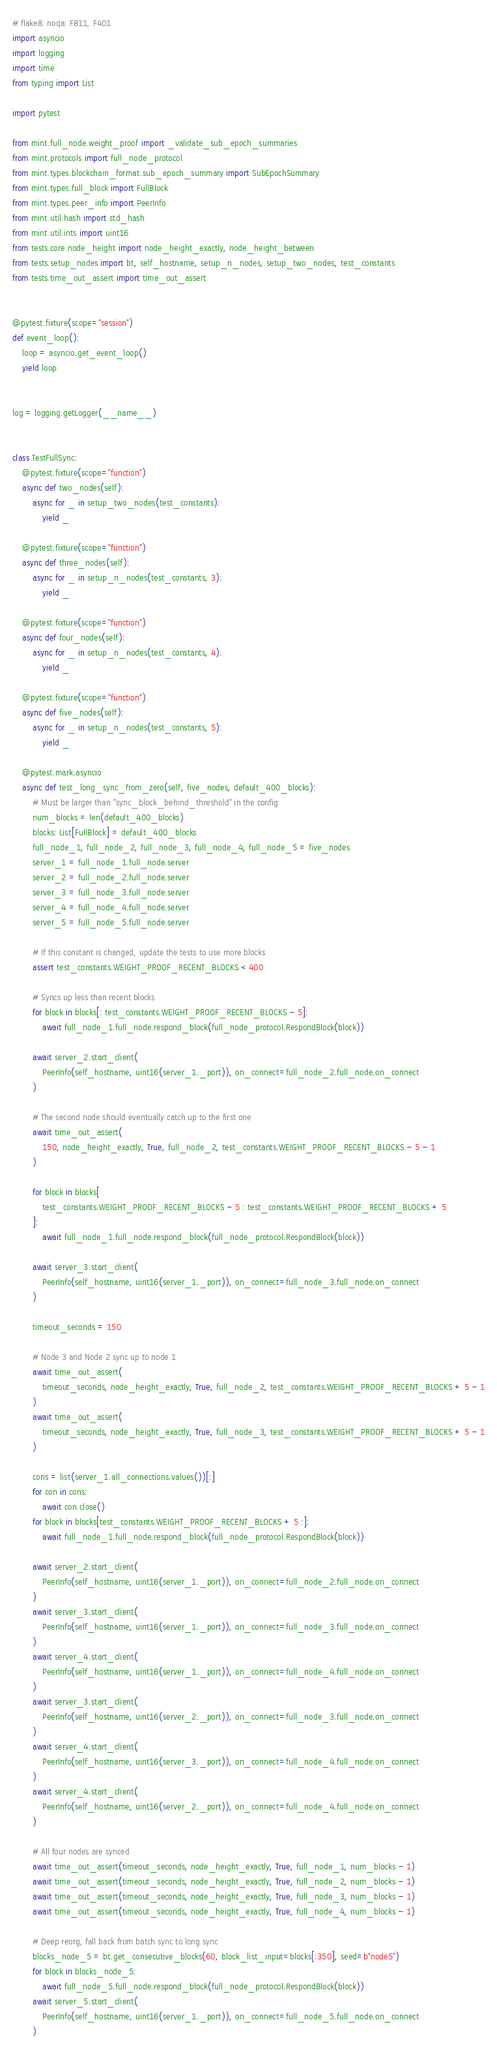<code> <loc_0><loc_0><loc_500><loc_500><_Python_># flake8: noqa: F811, F401
import asyncio
import logging
import time
from typing import List

import pytest

from mint.full_node.weight_proof import _validate_sub_epoch_summaries
from mint.protocols import full_node_protocol
from mint.types.blockchain_format.sub_epoch_summary import SubEpochSummary
from mint.types.full_block import FullBlock
from mint.types.peer_info import PeerInfo
from mint.util.hash import std_hash
from mint.util.ints import uint16
from tests.core.node_height import node_height_exactly, node_height_between
from tests.setup_nodes import bt, self_hostname, setup_n_nodes, setup_two_nodes, test_constants
from tests.time_out_assert import time_out_assert


@pytest.fixture(scope="session")
def event_loop():
    loop = asyncio.get_event_loop()
    yield loop


log = logging.getLogger(__name__)


class TestFullSync:
    @pytest.fixture(scope="function")
    async def two_nodes(self):
        async for _ in setup_two_nodes(test_constants):
            yield _

    @pytest.fixture(scope="function")
    async def three_nodes(self):
        async for _ in setup_n_nodes(test_constants, 3):
            yield _

    @pytest.fixture(scope="function")
    async def four_nodes(self):
        async for _ in setup_n_nodes(test_constants, 4):
            yield _

    @pytest.fixture(scope="function")
    async def five_nodes(self):
        async for _ in setup_n_nodes(test_constants, 5):
            yield _

    @pytest.mark.asyncio
    async def test_long_sync_from_zero(self, five_nodes, default_400_blocks):
        # Must be larger than "sync_block_behind_threshold" in the config
        num_blocks = len(default_400_blocks)
        blocks: List[FullBlock] = default_400_blocks
        full_node_1, full_node_2, full_node_3, full_node_4, full_node_5 = five_nodes
        server_1 = full_node_1.full_node.server
        server_2 = full_node_2.full_node.server
        server_3 = full_node_3.full_node.server
        server_4 = full_node_4.full_node.server
        server_5 = full_node_5.full_node.server

        # If this constant is changed, update the tests to use more blocks
        assert test_constants.WEIGHT_PROOF_RECENT_BLOCKS < 400

        # Syncs up less than recent blocks
        for block in blocks[: test_constants.WEIGHT_PROOF_RECENT_BLOCKS - 5]:
            await full_node_1.full_node.respond_block(full_node_protocol.RespondBlock(block))

        await server_2.start_client(
            PeerInfo(self_hostname, uint16(server_1._port)), on_connect=full_node_2.full_node.on_connect
        )

        # The second node should eventually catch up to the first one
        await time_out_assert(
            150, node_height_exactly, True, full_node_2, test_constants.WEIGHT_PROOF_RECENT_BLOCKS - 5 - 1
        )

        for block in blocks[
            test_constants.WEIGHT_PROOF_RECENT_BLOCKS - 5 : test_constants.WEIGHT_PROOF_RECENT_BLOCKS + 5
        ]:
            await full_node_1.full_node.respond_block(full_node_protocol.RespondBlock(block))

        await server_3.start_client(
            PeerInfo(self_hostname, uint16(server_1._port)), on_connect=full_node_3.full_node.on_connect
        )

        timeout_seconds = 150

        # Node 3 and Node 2 sync up to node 1
        await time_out_assert(
            timeout_seconds, node_height_exactly, True, full_node_2, test_constants.WEIGHT_PROOF_RECENT_BLOCKS + 5 - 1
        )
        await time_out_assert(
            timeout_seconds, node_height_exactly, True, full_node_3, test_constants.WEIGHT_PROOF_RECENT_BLOCKS + 5 - 1
        )

        cons = list(server_1.all_connections.values())[:]
        for con in cons:
            await con.close()
        for block in blocks[test_constants.WEIGHT_PROOF_RECENT_BLOCKS + 5 :]:
            await full_node_1.full_node.respond_block(full_node_protocol.RespondBlock(block))

        await server_2.start_client(
            PeerInfo(self_hostname, uint16(server_1._port)), on_connect=full_node_2.full_node.on_connect
        )
        await server_3.start_client(
            PeerInfo(self_hostname, uint16(server_1._port)), on_connect=full_node_3.full_node.on_connect
        )
        await server_4.start_client(
            PeerInfo(self_hostname, uint16(server_1._port)), on_connect=full_node_4.full_node.on_connect
        )
        await server_3.start_client(
            PeerInfo(self_hostname, uint16(server_2._port)), on_connect=full_node_3.full_node.on_connect
        )
        await server_4.start_client(
            PeerInfo(self_hostname, uint16(server_3._port)), on_connect=full_node_4.full_node.on_connect
        )
        await server_4.start_client(
            PeerInfo(self_hostname, uint16(server_2._port)), on_connect=full_node_4.full_node.on_connect
        )

        # All four nodes are synced
        await time_out_assert(timeout_seconds, node_height_exactly, True, full_node_1, num_blocks - 1)
        await time_out_assert(timeout_seconds, node_height_exactly, True, full_node_2, num_blocks - 1)
        await time_out_assert(timeout_seconds, node_height_exactly, True, full_node_3, num_blocks - 1)
        await time_out_assert(timeout_seconds, node_height_exactly, True, full_node_4, num_blocks - 1)

        # Deep reorg, fall back from batch sync to long sync
        blocks_node_5 = bt.get_consecutive_blocks(60, block_list_input=blocks[:350], seed=b"node5")
        for block in blocks_node_5:
            await full_node_5.full_node.respond_block(full_node_protocol.RespondBlock(block))
        await server_5.start_client(
            PeerInfo(self_hostname, uint16(server_1._port)), on_connect=full_node_5.full_node.on_connect
        )</code> 